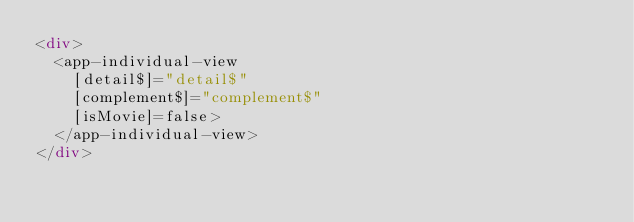Convert code to text. <code><loc_0><loc_0><loc_500><loc_500><_HTML_><div>
  <app-individual-view
    [detail$]="detail$"
    [complement$]="complement$"
    [isMovie]=false>
  </app-individual-view>
</div></code> 